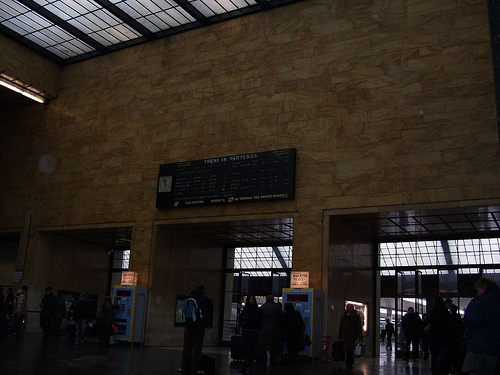<image>
Is there a board on the wall? Yes. Looking at the image, I can see the board is positioned on top of the wall, with the wall providing support. 